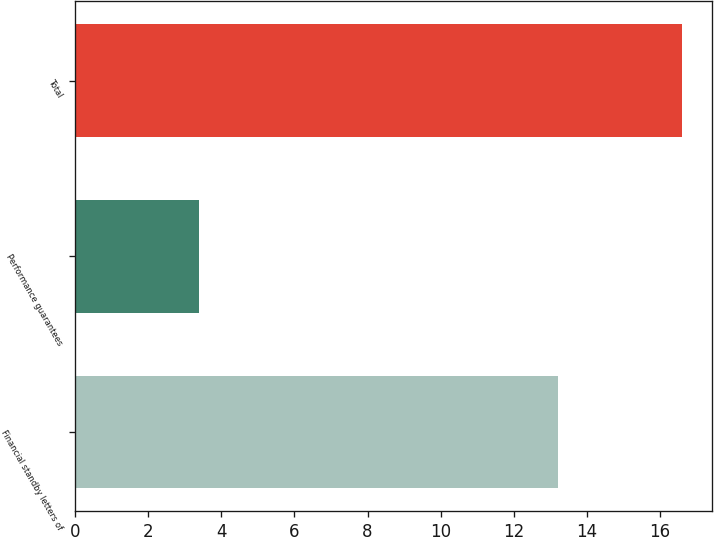Convert chart. <chart><loc_0><loc_0><loc_500><loc_500><bar_chart><fcel>Financial standby letters of<fcel>Performance guarantees<fcel>Total<nl><fcel>13.2<fcel>3.4<fcel>16.6<nl></chart> 